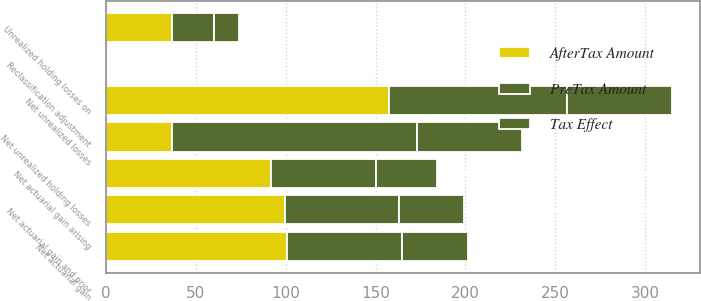Convert chart to OTSL. <chart><loc_0><loc_0><loc_500><loc_500><stacked_bar_chart><ecel><fcel>Net actuarial gain arising<fcel>Reclassification adjustment<fcel>Net actuarial gain<fcel>Net actuarial gain and prior<fcel>Net unrealized holding losses<fcel>Net unrealized losses<fcel>Unrealized holding losses on<nl><fcel>AfterTax Amount<fcel>92<fcel>1.1<fcel>100.8<fcel>99.7<fcel>37<fcel>157.4<fcel>37<nl><fcel>Tax Effect<fcel>33.7<fcel>0.4<fcel>36.9<fcel>36.5<fcel>58.1<fcel>58.1<fcel>13.7<nl><fcel>PreTax Amount<fcel>58.3<fcel>0.7<fcel>63.9<fcel>63.2<fcel>136.3<fcel>99.3<fcel>23.3<nl></chart> 